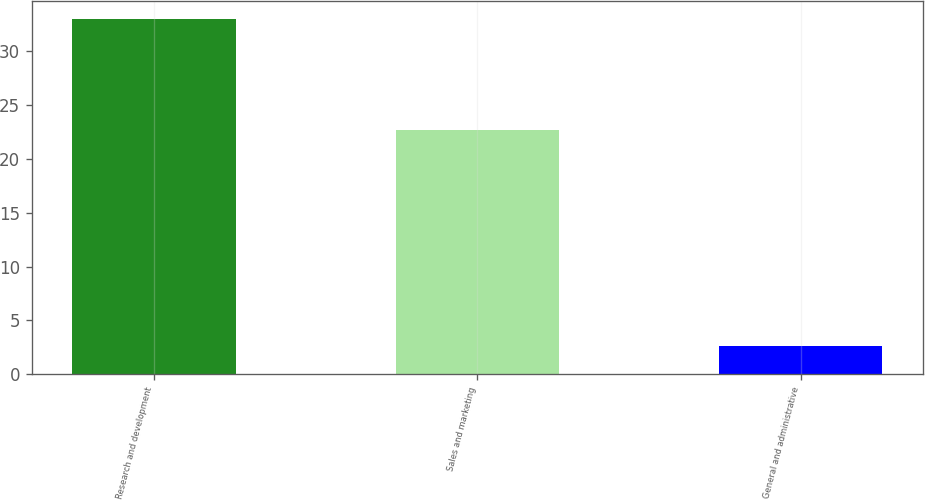Convert chart to OTSL. <chart><loc_0><loc_0><loc_500><loc_500><bar_chart><fcel>Research and development<fcel>Sales and marketing<fcel>General and administrative<nl><fcel>33<fcel>22.7<fcel>2.6<nl></chart> 